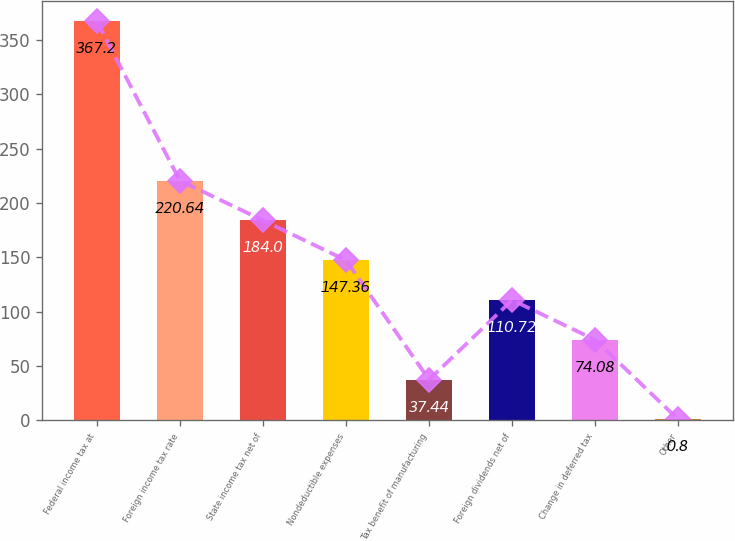Convert chart to OTSL. <chart><loc_0><loc_0><loc_500><loc_500><bar_chart><fcel>Federal income tax at<fcel>Foreign income tax rate<fcel>State income tax net of<fcel>Nondeductible expenses<fcel>Tax benefit of manufacturing<fcel>Foreign dividends net of<fcel>Change in deferred tax<fcel>Other<nl><fcel>367.2<fcel>220.64<fcel>184<fcel>147.36<fcel>37.44<fcel>110.72<fcel>74.08<fcel>0.8<nl></chart> 